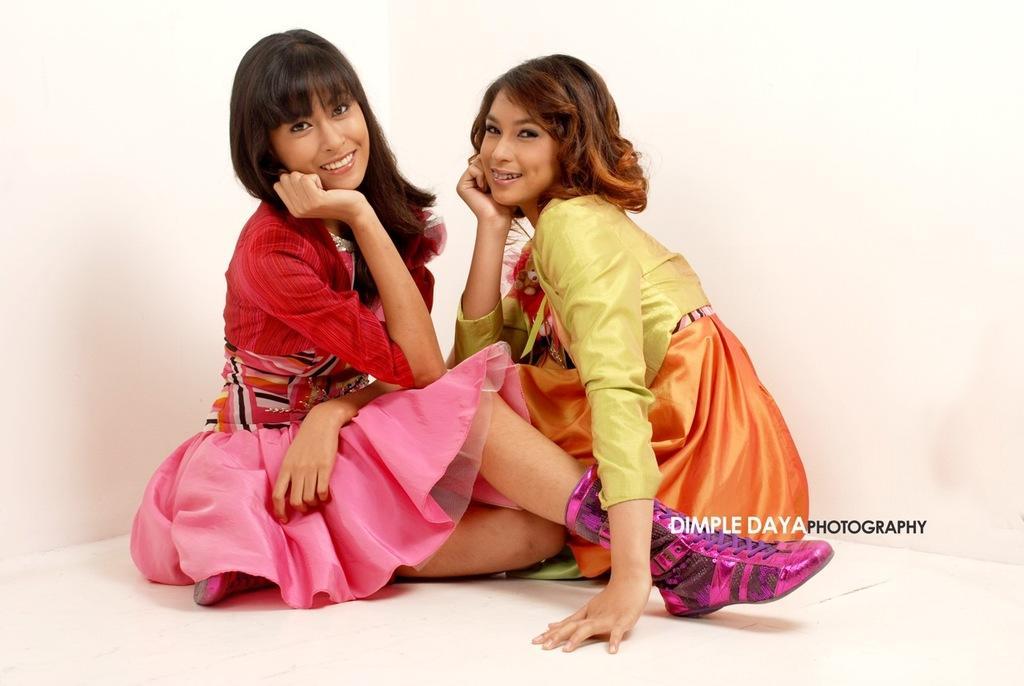How would you summarize this image in a sentence or two? In the middle of the image two women are sitting and smiling. Behind them we can see a wall. 